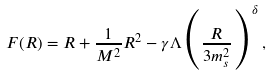<formula> <loc_0><loc_0><loc_500><loc_500>F ( R ) = R + \frac { 1 } { M ^ { 2 } } R ^ { 2 } - \gamma \Lambda \Big { ( } \frac { R } { 3 m _ { s } ^ { 2 } } \Big { ) } ^ { \delta } \, ,</formula> 